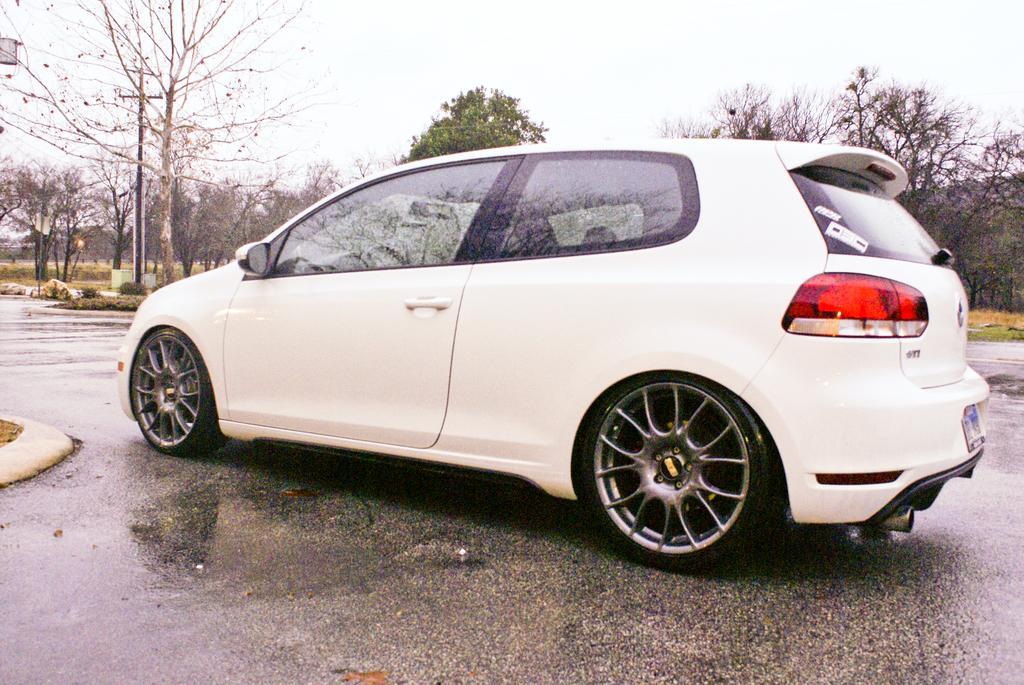Please provide a concise description of this image. In this image we see a vehicle on the road. There are many trees in the image. We can see the sky in the image. There is a grassy land in the image. 